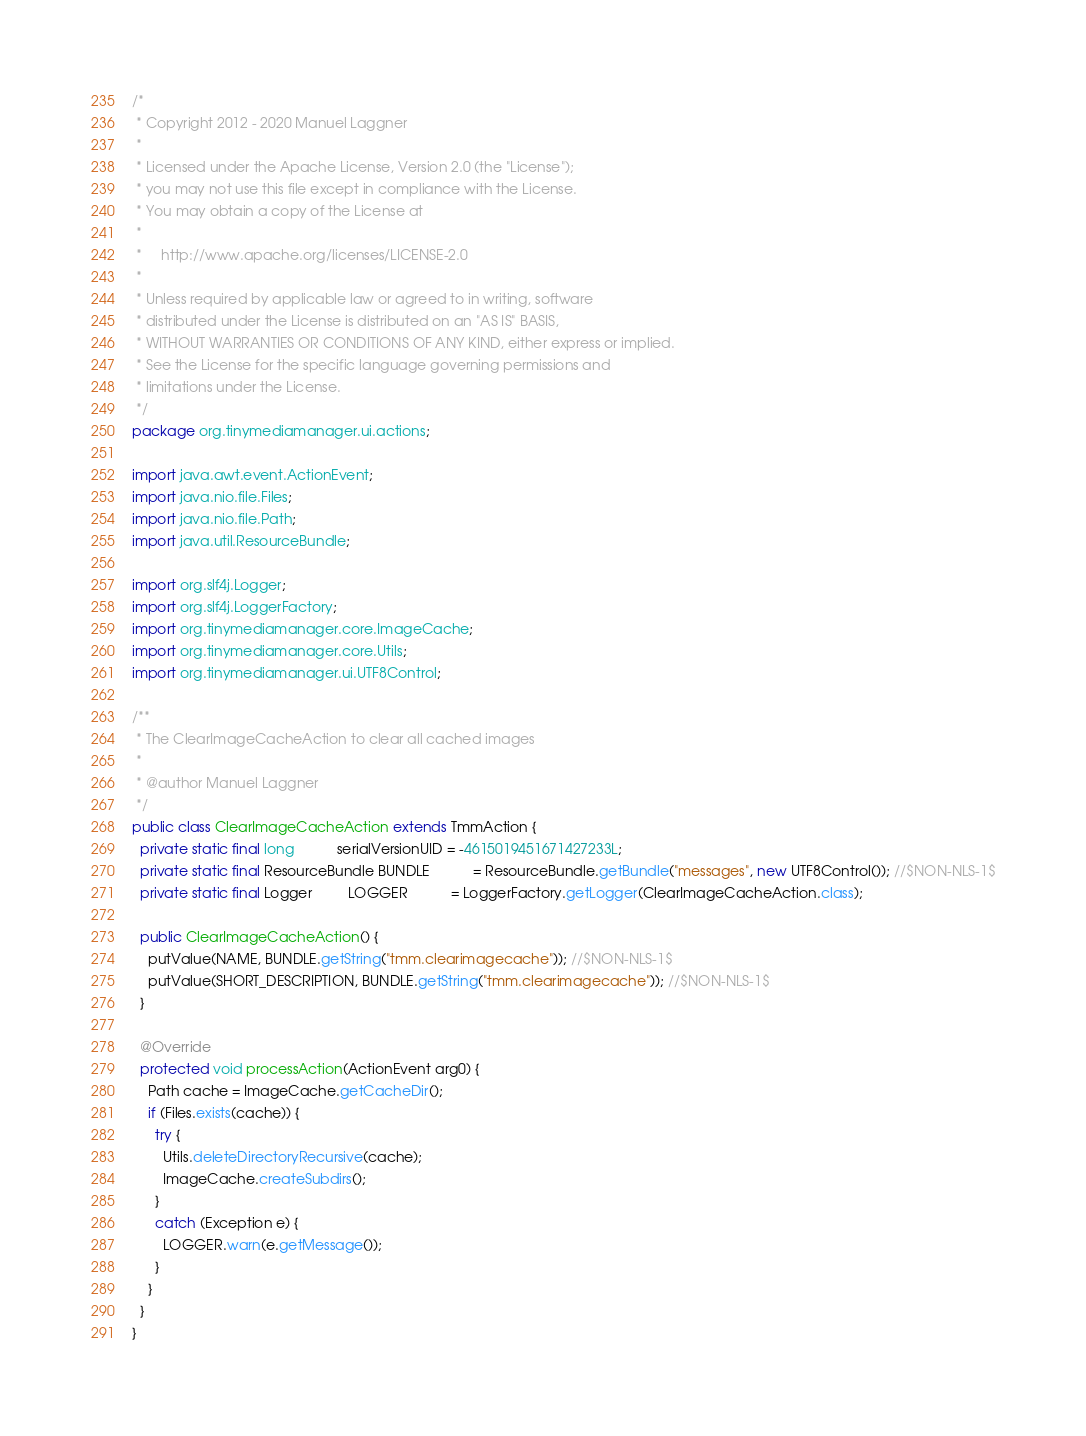<code> <loc_0><loc_0><loc_500><loc_500><_Java_>/*
 * Copyright 2012 - 2020 Manuel Laggner
 *
 * Licensed under the Apache License, Version 2.0 (the "License");
 * you may not use this file except in compliance with the License.
 * You may obtain a copy of the License at
 *
 *     http://www.apache.org/licenses/LICENSE-2.0
 *
 * Unless required by applicable law or agreed to in writing, software
 * distributed under the License is distributed on an "AS IS" BASIS,
 * WITHOUT WARRANTIES OR CONDITIONS OF ANY KIND, either express or implied.
 * See the License for the specific language governing permissions and
 * limitations under the License.
 */
package org.tinymediamanager.ui.actions;

import java.awt.event.ActionEvent;
import java.nio.file.Files;
import java.nio.file.Path;
import java.util.ResourceBundle;

import org.slf4j.Logger;
import org.slf4j.LoggerFactory;
import org.tinymediamanager.core.ImageCache;
import org.tinymediamanager.core.Utils;
import org.tinymediamanager.ui.UTF8Control;

/**
 * The ClearImageCacheAction to clear all cached images
 * 
 * @author Manuel Laggner
 */
public class ClearImageCacheAction extends TmmAction {
  private static final long           serialVersionUID = -4615019451671427233L;
  private static final ResourceBundle BUNDLE           = ResourceBundle.getBundle("messages", new UTF8Control()); //$NON-NLS-1$
  private static final Logger         LOGGER           = LoggerFactory.getLogger(ClearImageCacheAction.class);

  public ClearImageCacheAction() {
    putValue(NAME, BUNDLE.getString("tmm.clearimagecache")); //$NON-NLS-1$
    putValue(SHORT_DESCRIPTION, BUNDLE.getString("tmm.clearimagecache")); //$NON-NLS-1$
  }

  @Override
  protected void processAction(ActionEvent arg0) {
    Path cache = ImageCache.getCacheDir();
    if (Files.exists(cache)) {
      try {
        Utils.deleteDirectoryRecursive(cache);
        ImageCache.createSubdirs();
      }
      catch (Exception e) {
        LOGGER.warn(e.getMessage());
      }
    }
  }
}
</code> 